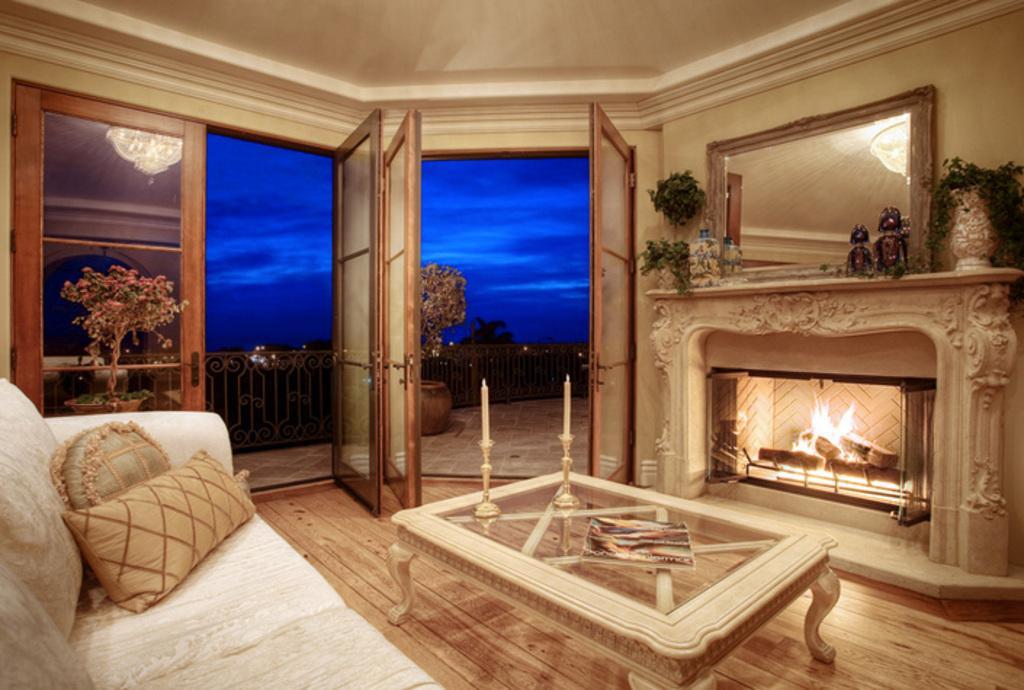Can you describe this image briefly? This image is clicked in a room. On the right side there is a fireplace and mirror on the right side top corner. There are flower pots, plants, there is a table in the middle. There are candles and candle stands on that table. There is also a book. There is a sofa on the right left side bottom corner. There is a door. There is a plant on the left side. 